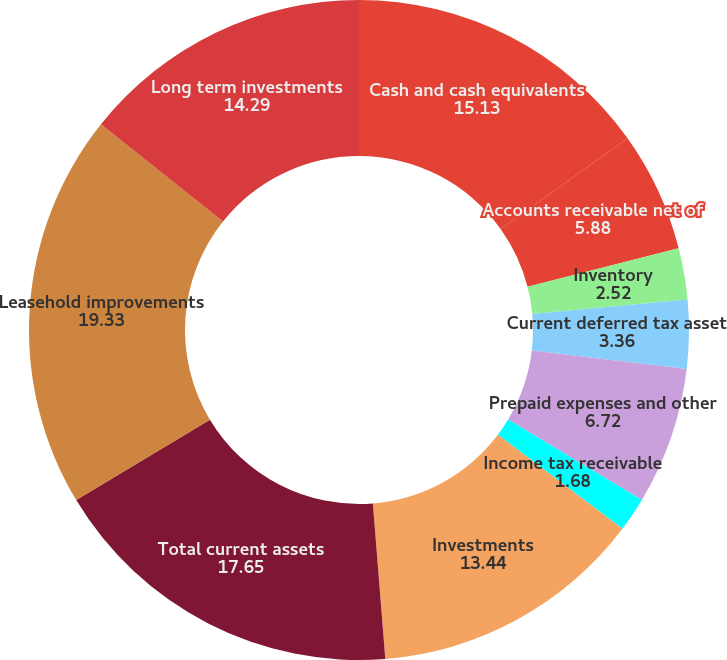<chart> <loc_0><loc_0><loc_500><loc_500><pie_chart><fcel>Cash and cash equivalents<fcel>Accounts receivable net of<fcel>Inventory<fcel>Current deferred tax asset<fcel>Prepaid expenses and other<fcel>Income tax receivable<fcel>Investments<fcel>Total current assets<fcel>Leasehold improvements<fcel>Long term investments<nl><fcel>15.13%<fcel>5.88%<fcel>2.52%<fcel>3.36%<fcel>6.72%<fcel>1.68%<fcel>13.44%<fcel>17.65%<fcel>19.33%<fcel>14.29%<nl></chart> 